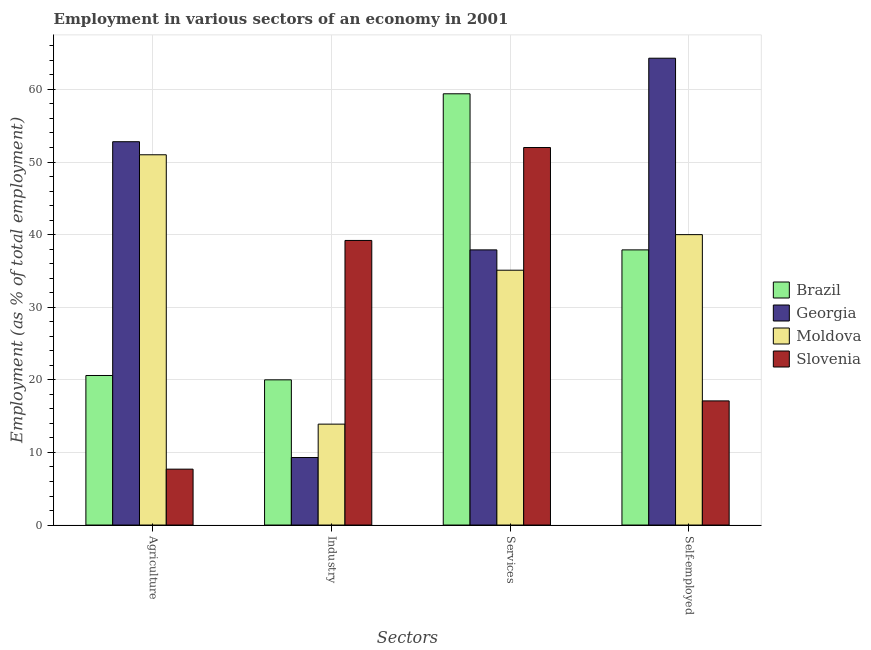How many different coloured bars are there?
Provide a short and direct response. 4. How many bars are there on the 3rd tick from the left?
Ensure brevity in your answer.  4. What is the label of the 3rd group of bars from the left?
Your answer should be very brief. Services. What is the percentage of workers in industry in Georgia?
Provide a short and direct response. 9.3. Across all countries, what is the maximum percentage of workers in industry?
Give a very brief answer. 39.2. Across all countries, what is the minimum percentage of workers in agriculture?
Provide a succinct answer. 7.7. In which country was the percentage of workers in services maximum?
Provide a succinct answer. Brazil. In which country was the percentage of workers in services minimum?
Provide a succinct answer. Moldova. What is the total percentage of workers in agriculture in the graph?
Your answer should be compact. 132.1. What is the difference between the percentage of workers in industry in Georgia and that in Brazil?
Offer a very short reply. -10.7. What is the difference between the percentage of self employed workers in Brazil and the percentage of workers in services in Moldova?
Your response must be concise. 2.8. What is the average percentage of workers in agriculture per country?
Give a very brief answer. 33.02. What is the difference between the percentage of workers in agriculture and percentage of self employed workers in Slovenia?
Offer a very short reply. -9.4. What is the ratio of the percentage of workers in agriculture in Slovenia to that in Brazil?
Give a very brief answer. 0.37. Is the percentage of self employed workers in Slovenia less than that in Georgia?
Provide a short and direct response. Yes. Is the difference between the percentage of workers in industry in Georgia and Moldova greater than the difference between the percentage of workers in agriculture in Georgia and Moldova?
Ensure brevity in your answer.  No. What is the difference between the highest and the second highest percentage of workers in services?
Offer a very short reply. 7.4. What is the difference between the highest and the lowest percentage of self employed workers?
Your response must be concise. 47.2. Is the sum of the percentage of workers in services in Slovenia and Georgia greater than the maximum percentage of self employed workers across all countries?
Your answer should be very brief. Yes. Is it the case that in every country, the sum of the percentage of self employed workers and percentage of workers in services is greater than the sum of percentage of workers in industry and percentage of workers in agriculture?
Ensure brevity in your answer.  No. What does the 4th bar from the left in Services represents?
Offer a terse response. Slovenia. What does the 3rd bar from the right in Services represents?
Offer a very short reply. Georgia. Is it the case that in every country, the sum of the percentage of workers in agriculture and percentage of workers in industry is greater than the percentage of workers in services?
Give a very brief answer. No. How many bars are there?
Ensure brevity in your answer.  16. Are all the bars in the graph horizontal?
Your answer should be very brief. No. How many countries are there in the graph?
Keep it short and to the point. 4. What is the difference between two consecutive major ticks on the Y-axis?
Provide a short and direct response. 10. Are the values on the major ticks of Y-axis written in scientific E-notation?
Offer a terse response. No. Does the graph contain any zero values?
Your answer should be compact. No. How many legend labels are there?
Your response must be concise. 4. How are the legend labels stacked?
Your response must be concise. Vertical. What is the title of the graph?
Your answer should be compact. Employment in various sectors of an economy in 2001. Does "Hungary" appear as one of the legend labels in the graph?
Make the answer very short. No. What is the label or title of the X-axis?
Your answer should be very brief. Sectors. What is the label or title of the Y-axis?
Your answer should be very brief. Employment (as % of total employment). What is the Employment (as % of total employment) in Brazil in Agriculture?
Provide a succinct answer. 20.6. What is the Employment (as % of total employment) in Georgia in Agriculture?
Ensure brevity in your answer.  52.8. What is the Employment (as % of total employment) of Moldova in Agriculture?
Give a very brief answer. 51. What is the Employment (as % of total employment) of Slovenia in Agriculture?
Ensure brevity in your answer.  7.7. What is the Employment (as % of total employment) of Georgia in Industry?
Offer a terse response. 9.3. What is the Employment (as % of total employment) of Moldova in Industry?
Your answer should be compact. 13.9. What is the Employment (as % of total employment) of Slovenia in Industry?
Your answer should be very brief. 39.2. What is the Employment (as % of total employment) of Brazil in Services?
Provide a succinct answer. 59.4. What is the Employment (as % of total employment) in Georgia in Services?
Provide a short and direct response. 37.9. What is the Employment (as % of total employment) in Moldova in Services?
Offer a terse response. 35.1. What is the Employment (as % of total employment) of Slovenia in Services?
Make the answer very short. 52. What is the Employment (as % of total employment) in Brazil in Self-employed?
Your answer should be very brief. 37.9. What is the Employment (as % of total employment) of Georgia in Self-employed?
Provide a short and direct response. 64.3. What is the Employment (as % of total employment) in Slovenia in Self-employed?
Your answer should be very brief. 17.1. Across all Sectors, what is the maximum Employment (as % of total employment) in Brazil?
Keep it short and to the point. 59.4. Across all Sectors, what is the maximum Employment (as % of total employment) in Georgia?
Your response must be concise. 64.3. Across all Sectors, what is the maximum Employment (as % of total employment) in Moldova?
Ensure brevity in your answer.  51. Across all Sectors, what is the maximum Employment (as % of total employment) of Slovenia?
Your response must be concise. 52. Across all Sectors, what is the minimum Employment (as % of total employment) of Brazil?
Keep it short and to the point. 20. Across all Sectors, what is the minimum Employment (as % of total employment) in Georgia?
Make the answer very short. 9.3. Across all Sectors, what is the minimum Employment (as % of total employment) of Moldova?
Offer a terse response. 13.9. Across all Sectors, what is the minimum Employment (as % of total employment) of Slovenia?
Offer a terse response. 7.7. What is the total Employment (as % of total employment) in Brazil in the graph?
Ensure brevity in your answer.  137.9. What is the total Employment (as % of total employment) in Georgia in the graph?
Provide a short and direct response. 164.3. What is the total Employment (as % of total employment) of Moldova in the graph?
Make the answer very short. 140. What is the total Employment (as % of total employment) in Slovenia in the graph?
Keep it short and to the point. 116. What is the difference between the Employment (as % of total employment) in Brazil in Agriculture and that in Industry?
Give a very brief answer. 0.6. What is the difference between the Employment (as % of total employment) in Georgia in Agriculture and that in Industry?
Your answer should be compact. 43.5. What is the difference between the Employment (as % of total employment) in Moldova in Agriculture and that in Industry?
Your answer should be very brief. 37.1. What is the difference between the Employment (as % of total employment) in Slovenia in Agriculture and that in Industry?
Give a very brief answer. -31.5. What is the difference between the Employment (as % of total employment) of Brazil in Agriculture and that in Services?
Offer a very short reply. -38.8. What is the difference between the Employment (as % of total employment) in Moldova in Agriculture and that in Services?
Your answer should be very brief. 15.9. What is the difference between the Employment (as % of total employment) of Slovenia in Agriculture and that in Services?
Ensure brevity in your answer.  -44.3. What is the difference between the Employment (as % of total employment) of Brazil in Agriculture and that in Self-employed?
Ensure brevity in your answer.  -17.3. What is the difference between the Employment (as % of total employment) in Brazil in Industry and that in Services?
Your answer should be very brief. -39.4. What is the difference between the Employment (as % of total employment) in Georgia in Industry and that in Services?
Offer a terse response. -28.6. What is the difference between the Employment (as % of total employment) of Moldova in Industry and that in Services?
Offer a terse response. -21.2. What is the difference between the Employment (as % of total employment) in Brazil in Industry and that in Self-employed?
Give a very brief answer. -17.9. What is the difference between the Employment (as % of total employment) of Georgia in Industry and that in Self-employed?
Provide a succinct answer. -55. What is the difference between the Employment (as % of total employment) in Moldova in Industry and that in Self-employed?
Your response must be concise. -26.1. What is the difference between the Employment (as % of total employment) in Slovenia in Industry and that in Self-employed?
Give a very brief answer. 22.1. What is the difference between the Employment (as % of total employment) of Georgia in Services and that in Self-employed?
Keep it short and to the point. -26.4. What is the difference between the Employment (as % of total employment) in Slovenia in Services and that in Self-employed?
Keep it short and to the point. 34.9. What is the difference between the Employment (as % of total employment) of Brazil in Agriculture and the Employment (as % of total employment) of Georgia in Industry?
Your response must be concise. 11.3. What is the difference between the Employment (as % of total employment) in Brazil in Agriculture and the Employment (as % of total employment) in Moldova in Industry?
Keep it short and to the point. 6.7. What is the difference between the Employment (as % of total employment) of Brazil in Agriculture and the Employment (as % of total employment) of Slovenia in Industry?
Offer a very short reply. -18.6. What is the difference between the Employment (as % of total employment) in Georgia in Agriculture and the Employment (as % of total employment) in Moldova in Industry?
Your answer should be very brief. 38.9. What is the difference between the Employment (as % of total employment) of Brazil in Agriculture and the Employment (as % of total employment) of Georgia in Services?
Provide a succinct answer. -17.3. What is the difference between the Employment (as % of total employment) of Brazil in Agriculture and the Employment (as % of total employment) of Moldova in Services?
Provide a succinct answer. -14.5. What is the difference between the Employment (as % of total employment) in Brazil in Agriculture and the Employment (as % of total employment) in Slovenia in Services?
Offer a terse response. -31.4. What is the difference between the Employment (as % of total employment) of Moldova in Agriculture and the Employment (as % of total employment) of Slovenia in Services?
Offer a terse response. -1. What is the difference between the Employment (as % of total employment) in Brazil in Agriculture and the Employment (as % of total employment) in Georgia in Self-employed?
Your response must be concise. -43.7. What is the difference between the Employment (as % of total employment) of Brazil in Agriculture and the Employment (as % of total employment) of Moldova in Self-employed?
Provide a short and direct response. -19.4. What is the difference between the Employment (as % of total employment) in Georgia in Agriculture and the Employment (as % of total employment) in Slovenia in Self-employed?
Give a very brief answer. 35.7. What is the difference between the Employment (as % of total employment) of Moldova in Agriculture and the Employment (as % of total employment) of Slovenia in Self-employed?
Your answer should be very brief. 33.9. What is the difference between the Employment (as % of total employment) of Brazil in Industry and the Employment (as % of total employment) of Georgia in Services?
Offer a terse response. -17.9. What is the difference between the Employment (as % of total employment) of Brazil in Industry and the Employment (as % of total employment) of Moldova in Services?
Offer a terse response. -15.1. What is the difference between the Employment (as % of total employment) of Brazil in Industry and the Employment (as % of total employment) of Slovenia in Services?
Give a very brief answer. -32. What is the difference between the Employment (as % of total employment) of Georgia in Industry and the Employment (as % of total employment) of Moldova in Services?
Give a very brief answer. -25.8. What is the difference between the Employment (as % of total employment) in Georgia in Industry and the Employment (as % of total employment) in Slovenia in Services?
Your answer should be very brief. -42.7. What is the difference between the Employment (as % of total employment) in Moldova in Industry and the Employment (as % of total employment) in Slovenia in Services?
Keep it short and to the point. -38.1. What is the difference between the Employment (as % of total employment) in Brazil in Industry and the Employment (as % of total employment) in Georgia in Self-employed?
Your answer should be very brief. -44.3. What is the difference between the Employment (as % of total employment) in Brazil in Industry and the Employment (as % of total employment) in Slovenia in Self-employed?
Make the answer very short. 2.9. What is the difference between the Employment (as % of total employment) of Georgia in Industry and the Employment (as % of total employment) of Moldova in Self-employed?
Keep it short and to the point. -30.7. What is the difference between the Employment (as % of total employment) of Georgia in Industry and the Employment (as % of total employment) of Slovenia in Self-employed?
Offer a very short reply. -7.8. What is the difference between the Employment (as % of total employment) in Moldova in Industry and the Employment (as % of total employment) in Slovenia in Self-employed?
Provide a short and direct response. -3.2. What is the difference between the Employment (as % of total employment) of Brazil in Services and the Employment (as % of total employment) of Moldova in Self-employed?
Your answer should be very brief. 19.4. What is the difference between the Employment (as % of total employment) in Brazil in Services and the Employment (as % of total employment) in Slovenia in Self-employed?
Your response must be concise. 42.3. What is the difference between the Employment (as % of total employment) in Georgia in Services and the Employment (as % of total employment) in Moldova in Self-employed?
Offer a very short reply. -2.1. What is the difference between the Employment (as % of total employment) in Georgia in Services and the Employment (as % of total employment) in Slovenia in Self-employed?
Make the answer very short. 20.8. What is the difference between the Employment (as % of total employment) in Moldova in Services and the Employment (as % of total employment) in Slovenia in Self-employed?
Offer a terse response. 18. What is the average Employment (as % of total employment) in Brazil per Sectors?
Offer a very short reply. 34.48. What is the average Employment (as % of total employment) in Georgia per Sectors?
Provide a short and direct response. 41.08. What is the average Employment (as % of total employment) of Moldova per Sectors?
Your answer should be very brief. 35. What is the average Employment (as % of total employment) in Slovenia per Sectors?
Offer a very short reply. 29. What is the difference between the Employment (as % of total employment) in Brazil and Employment (as % of total employment) in Georgia in Agriculture?
Ensure brevity in your answer.  -32.2. What is the difference between the Employment (as % of total employment) in Brazil and Employment (as % of total employment) in Moldova in Agriculture?
Your answer should be compact. -30.4. What is the difference between the Employment (as % of total employment) of Georgia and Employment (as % of total employment) of Moldova in Agriculture?
Your answer should be compact. 1.8. What is the difference between the Employment (as % of total employment) of Georgia and Employment (as % of total employment) of Slovenia in Agriculture?
Offer a very short reply. 45.1. What is the difference between the Employment (as % of total employment) of Moldova and Employment (as % of total employment) of Slovenia in Agriculture?
Keep it short and to the point. 43.3. What is the difference between the Employment (as % of total employment) of Brazil and Employment (as % of total employment) of Georgia in Industry?
Ensure brevity in your answer.  10.7. What is the difference between the Employment (as % of total employment) in Brazil and Employment (as % of total employment) in Moldova in Industry?
Provide a short and direct response. 6.1. What is the difference between the Employment (as % of total employment) in Brazil and Employment (as % of total employment) in Slovenia in Industry?
Provide a short and direct response. -19.2. What is the difference between the Employment (as % of total employment) of Georgia and Employment (as % of total employment) of Slovenia in Industry?
Make the answer very short. -29.9. What is the difference between the Employment (as % of total employment) in Moldova and Employment (as % of total employment) in Slovenia in Industry?
Make the answer very short. -25.3. What is the difference between the Employment (as % of total employment) in Brazil and Employment (as % of total employment) in Georgia in Services?
Provide a short and direct response. 21.5. What is the difference between the Employment (as % of total employment) in Brazil and Employment (as % of total employment) in Moldova in Services?
Your answer should be compact. 24.3. What is the difference between the Employment (as % of total employment) of Brazil and Employment (as % of total employment) of Slovenia in Services?
Your response must be concise. 7.4. What is the difference between the Employment (as % of total employment) of Georgia and Employment (as % of total employment) of Slovenia in Services?
Provide a short and direct response. -14.1. What is the difference between the Employment (as % of total employment) in Moldova and Employment (as % of total employment) in Slovenia in Services?
Give a very brief answer. -16.9. What is the difference between the Employment (as % of total employment) of Brazil and Employment (as % of total employment) of Georgia in Self-employed?
Your answer should be compact. -26.4. What is the difference between the Employment (as % of total employment) of Brazil and Employment (as % of total employment) of Slovenia in Self-employed?
Offer a terse response. 20.8. What is the difference between the Employment (as % of total employment) of Georgia and Employment (as % of total employment) of Moldova in Self-employed?
Give a very brief answer. 24.3. What is the difference between the Employment (as % of total employment) of Georgia and Employment (as % of total employment) of Slovenia in Self-employed?
Keep it short and to the point. 47.2. What is the difference between the Employment (as % of total employment) in Moldova and Employment (as % of total employment) in Slovenia in Self-employed?
Provide a succinct answer. 22.9. What is the ratio of the Employment (as % of total employment) of Georgia in Agriculture to that in Industry?
Make the answer very short. 5.68. What is the ratio of the Employment (as % of total employment) in Moldova in Agriculture to that in Industry?
Your answer should be compact. 3.67. What is the ratio of the Employment (as % of total employment) of Slovenia in Agriculture to that in Industry?
Keep it short and to the point. 0.2. What is the ratio of the Employment (as % of total employment) in Brazil in Agriculture to that in Services?
Provide a succinct answer. 0.35. What is the ratio of the Employment (as % of total employment) in Georgia in Agriculture to that in Services?
Your answer should be compact. 1.39. What is the ratio of the Employment (as % of total employment) of Moldova in Agriculture to that in Services?
Provide a succinct answer. 1.45. What is the ratio of the Employment (as % of total employment) of Slovenia in Agriculture to that in Services?
Your answer should be compact. 0.15. What is the ratio of the Employment (as % of total employment) of Brazil in Agriculture to that in Self-employed?
Provide a succinct answer. 0.54. What is the ratio of the Employment (as % of total employment) of Georgia in Agriculture to that in Self-employed?
Ensure brevity in your answer.  0.82. What is the ratio of the Employment (as % of total employment) of Moldova in Agriculture to that in Self-employed?
Ensure brevity in your answer.  1.27. What is the ratio of the Employment (as % of total employment) of Slovenia in Agriculture to that in Self-employed?
Keep it short and to the point. 0.45. What is the ratio of the Employment (as % of total employment) of Brazil in Industry to that in Services?
Your answer should be compact. 0.34. What is the ratio of the Employment (as % of total employment) of Georgia in Industry to that in Services?
Make the answer very short. 0.25. What is the ratio of the Employment (as % of total employment) of Moldova in Industry to that in Services?
Give a very brief answer. 0.4. What is the ratio of the Employment (as % of total employment) of Slovenia in Industry to that in Services?
Keep it short and to the point. 0.75. What is the ratio of the Employment (as % of total employment) of Brazil in Industry to that in Self-employed?
Offer a terse response. 0.53. What is the ratio of the Employment (as % of total employment) of Georgia in Industry to that in Self-employed?
Your answer should be very brief. 0.14. What is the ratio of the Employment (as % of total employment) of Moldova in Industry to that in Self-employed?
Your response must be concise. 0.35. What is the ratio of the Employment (as % of total employment) of Slovenia in Industry to that in Self-employed?
Your response must be concise. 2.29. What is the ratio of the Employment (as % of total employment) of Brazil in Services to that in Self-employed?
Keep it short and to the point. 1.57. What is the ratio of the Employment (as % of total employment) in Georgia in Services to that in Self-employed?
Your answer should be very brief. 0.59. What is the ratio of the Employment (as % of total employment) of Moldova in Services to that in Self-employed?
Make the answer very short. 0.88. What is the ratio of the Employment (as % of total employment) of Slovenia in Services to that in Self-employed?
Provide a succinct answer. 3.04. What is the difference between the highest and the second highest Employment (as % of total employment) in Slovenia?
Your response must be concise. 12.8. What is the difference between the highest and the lowest Employment (as % of total employment) in Brazil?
Keep it short and to the point. 39.4. What is the difference between the highest and the lowest Employment (as % of total employment) of Moldova?
Keep it short and to the point. 37.1. What is the difference between the highest and the lowest Employment (as % of total employment) in Slovenia?
Offer a very short reply. 44.3. 